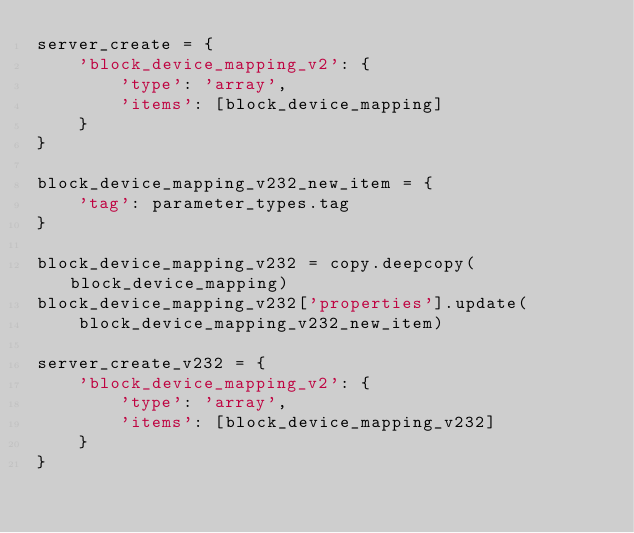<code> <loc_0><loc_0><loc_500><loc_500><_Python_>server_create = {
    'block_device_mapping_v2': {
        'type': 'array',
        'items': [block_device_mapping]
    }
}

block_device_mapping_v232_new_item = {
    'tag': parameter_types.tag
}

block_device_mapping_v232 = copy.deepcopy(block_device_mapping)
block_device_mapping_v232['properties'].update(
    block_device_mapping_v232_new_item)

server_create_v232 = {
    'block_device_mapping_v2': {
        'type': 'array',
        'items': [block_device_mapping_v232]
    }
}
</code> 